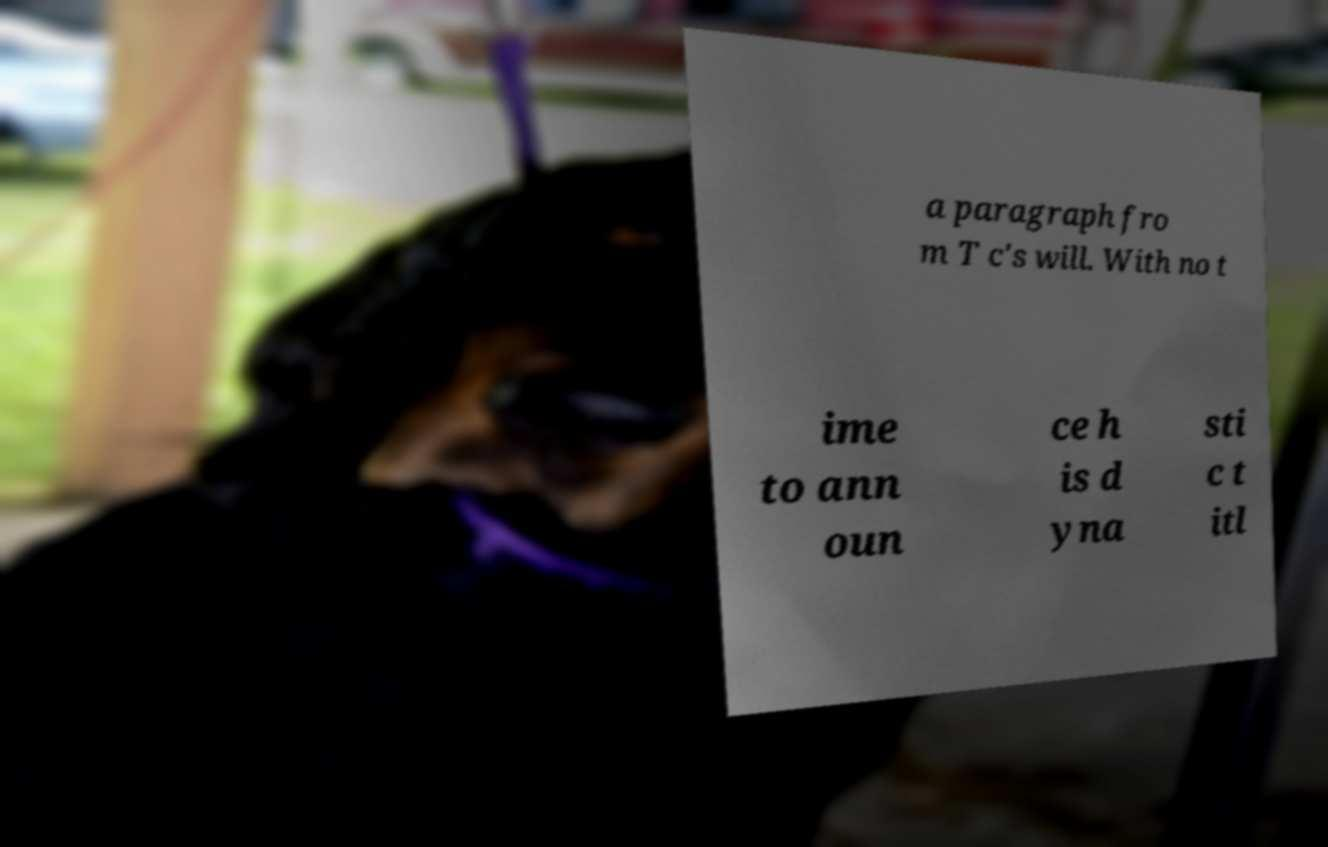Could you extract and type out the text from this image? a paragraph fro m T c's will. With no t ime to ann oun ce h is d yna sti c t itl 